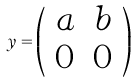Convert formula to latex. <formula><loc_0><loc_0><loc_500><loc_500>y = \left ( \begin{array} { c c } a & b \\ 0 & 0 \end{array} \right )</formula> 